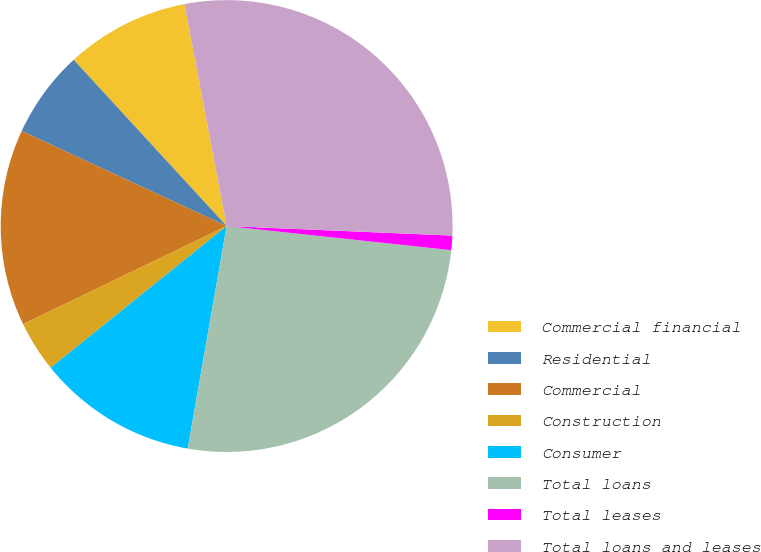Convert chart. <chart><loc_0><loc_0><loc_500><loc_500><pie_chart><fcel>Commercial financial<fcel>Residential<fcel>Commercial<fcel>Construction<fcel>Consumer<fcel>Total loans<fcel>Total leases<fcel>Total loans and leases<nl><fcel>8.85%<fcel>6.25%<fcel>14.06%<fcel>3.64%<fcel>11.46%<fcel>26.05%<fcel>1.03%<fcel>28.66%<nl></chart> 